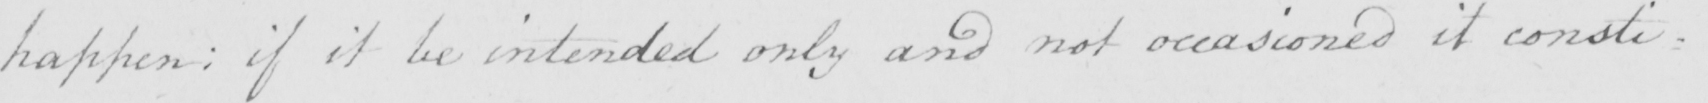Can you read and transcribe this handwriting? happen :  if it be intended only and not occasioned it consti= 